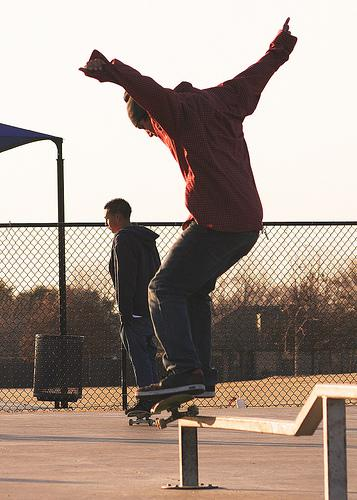Focus on the main character's features and their main activity in the image. A male skateboarder with outstretched arms and wearing a cap on head is performing a trick on a rail. Focus on the objects seen in the background of the main subject and their action. A man on a skateboard performs a stunt on a rail, with a chain linked fence, a building, and a garbage can with holes as part of the backdrop. Depict the central action-taking place, highlighting the main character's outfit. A skateboarder, dressed in a red jacket and a cap, rides the rail after coming off a ramp, with arms outstretched for balance. In a single sentence, describe the primary action happening in the image. The skateboarder in a red jacket is coming off a ramp and attempting a stunt on a rail. Describe the atmosphere and environment in the image along with the main subject. A skateboarder is performing a trick on a rail with a clear, cloudless sky overhead, a chain linked fence in the back, and a black waste bin nearby. Describe the main subject and the challenge he is facing while performing the action. A male skateboarder wearing a cap is trying to maintain balance while executing a stunt on a rusty rail, coming off a ramp. Mention the main subject and some noticeable details about them from the image. A skateboarder in a red jacket and cap has his arms outstretched while performing a trick on the rail, with a rusted ramp in the background. Elaborate on the image's central subject and their surroundings. A man wearing a red jacket and cap is skateboarding off a ramp onto a rail, surrounded by a chain linked fence and a building in the background. Mention the core action and the main figure performing it in the image. A person is skateboarding on a rail, wearing a red jacket and cap. Illustrate the main subject and their position in the image, with contextual details. A person standing on a skateboard rides a rail with outstretched arms, as a building, a chain linked fence, and a rusted ramp fill the scene behind him. 